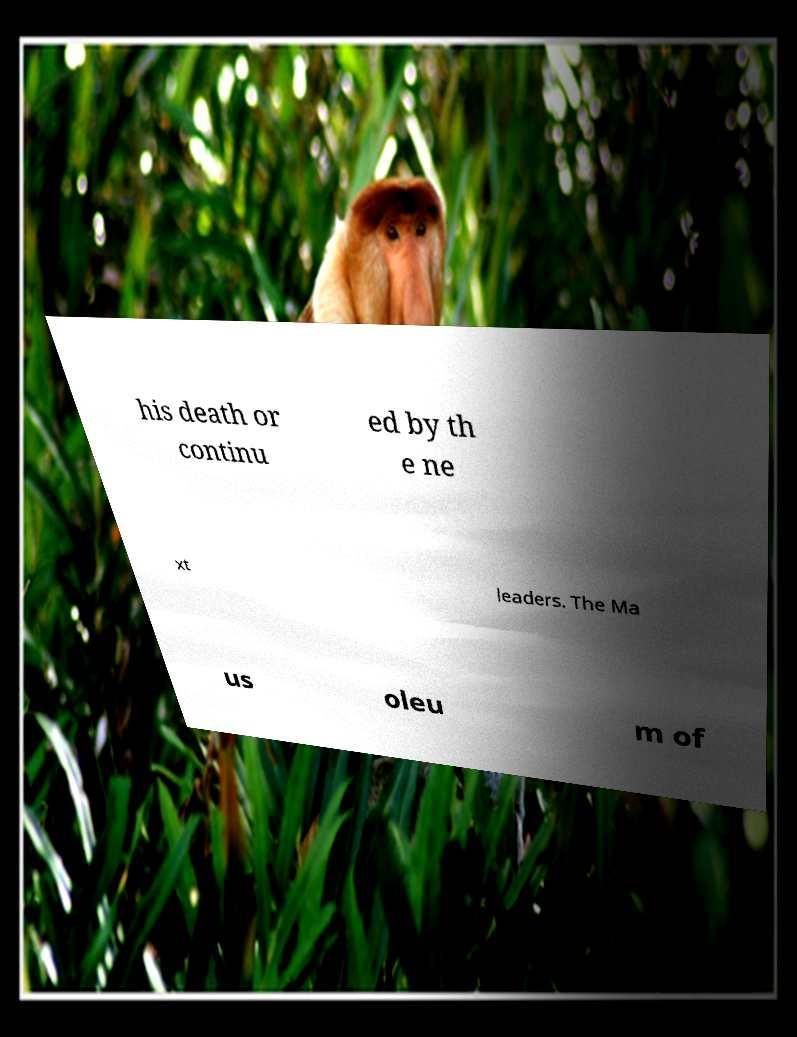I need the written content from this picture converted into text. Can you do that? his death or continu ed by th e ne xt leaders. The Ma us oleu m of 